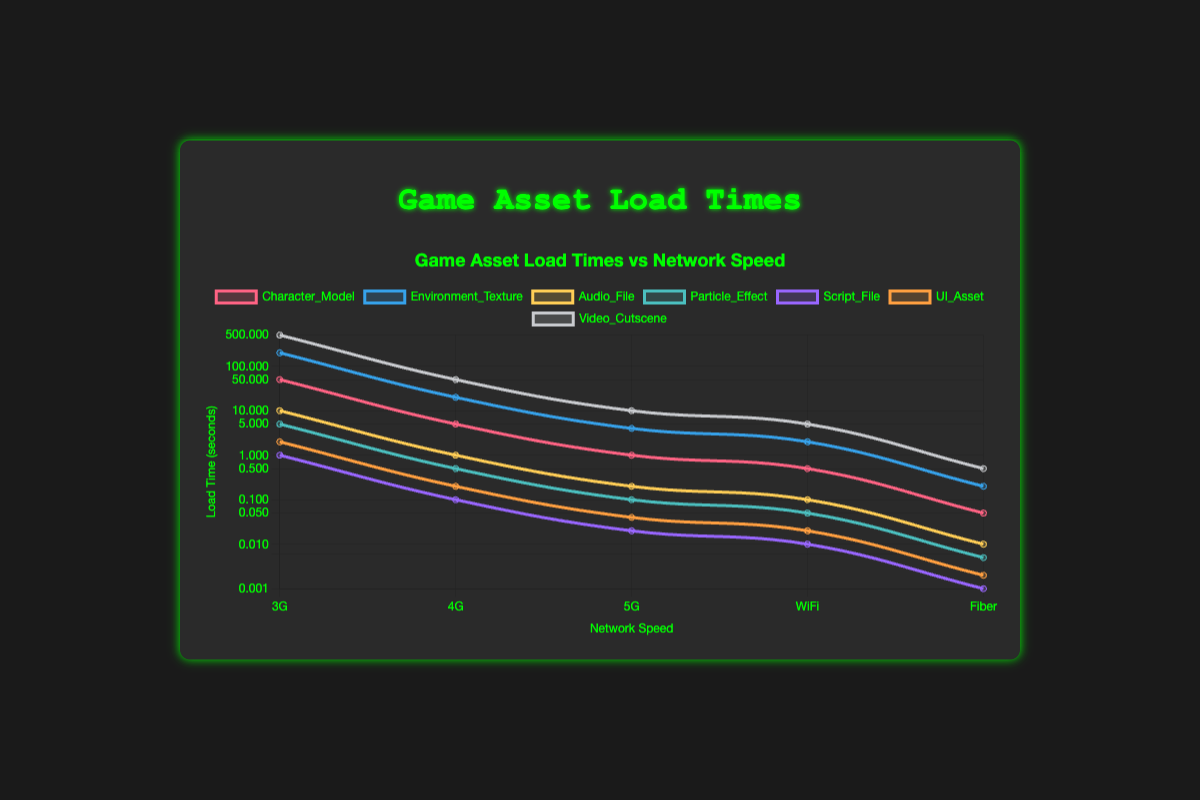What is the load time for the "Character_Model" asset on a 5G network? Look for the "Character_Model" dataset and follow the line to the point corresponding to the 5G network. The value is 1 second.
Answer: 1 second Which asset has the longest load time on a 4G network? Among the plotted datasets, identify the one with the highest value at the 4G network point. "Video_Cutscene" has the longest load time at 50 seconds.
Answer: Video_Cutscene How does the load time of "Audio_File" compare between WiFi and Fiber networks? Compare the load times for "Audio_File" on WiFi and Fiber networks. The load times are 0.1 seconds for WiFi and 0.01 seconds for Fiber, showing that WiFi is 10 times slower.
Answer: WiFi is 10 times slower What is the average load time for the "Environment_Texture" asset across all network types? Sum the "Environment_Texture" load times for all network types and divide by the number of types (5). The sum is 200 + 20 + 4 + 2 + 0.2 = 226.2 seconds, average is 226.2 / 5 = 45.24 seconds.
Answer: 45.24 seconds By what factor does the load time of the "Particle_Effect" asset decrease from 4G to Fiber? Calculate the load times for "Particle_Effect" at 4G and Fiber, then divide the 4G time by the Fiber time. The times are 0.5 seconds for 4G and 0.005 seconds for Fiber, so 0.5 / 0.005 = 100.
Answer: 100 Compare the load time difference between "UI_Asset" and "Script_File" on a 3G network. Subtract the "Script_File" load time from the "UI_Asset" load time for 3G. The times are 2 seconds for UI_Asset and 1 second for Script_File, so 2 - 1 = 1 second.
Answer: 1 second What is the visual color of the line representing the "Video_Cutscene" asset? Identify the color used for the "Video_Cutscene" according to the figure legend; it appears as the distinct color differentially assigned to its line. It is represented by a particular hue in the chart legend.
Answer: Red Which network speed shows the smallest variation in load times across all assets? Examine all network speeds and their variation in load times for different assets. Identify which network exhibits the smallest range of values. The smallest variation is most likely on the Fiber network.
Answer: Fiber network How many times faster does the "Character_Model" load on WiFi compared to 3G? Divide the 3G load time by the WiFi load time for "Character_Model". The times are 50 seconds for 3G and 0.5 seconds for WiFi, leading to 50 / 0.5 = 100 times faster.
Answer: 100 times What is the load time ratio of "Environment_Texture" on 5G versus "Character_Model" on 4G? Divide the "Environment_Texture" load time on 5G by the "Character_Model" load time on 4G. The times are 4 seconds for Environment_Texture on 5G and 5 seconds for Character_Model on 4G, so 4 / 5 = 0.8.
Answer: 0.8 